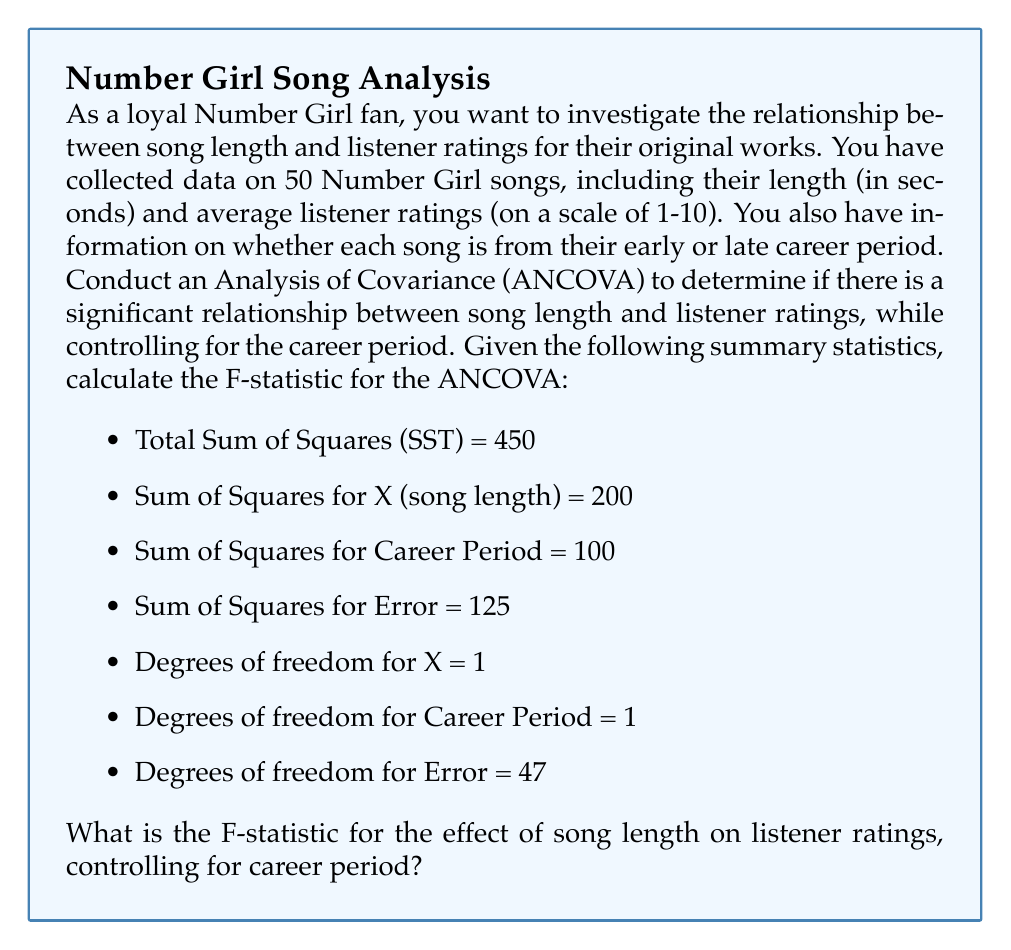Show me your answer to this math problem. To calculate the F-statistic for the effect of song length on listener ratings while controlling for career period, we need to follow these steps:

1. Calculate the Sum of Squares for the covariate (song length) after adjusting for the career period:

   $SS_{X.adj} = SS_X - \frac{(SS_{CP} \times SS_X)}{SST}$

   Where $SS_{X.adj}$ is the adjusted Sum of Squares for X, $SS_X$ is the Sum of Squares for X, $SS_{CP}$ is the Sum of Squares for Career Period, and $SST$ is the Total Sum of Squares.

   $SS_{X.adj} = 200 - \frac{(100 \times 200)}{450} = 200 - 44.44 = 155.56$

2. Calculate the Mean Square for the adjusted X:

   $MS_{X.adj} = \frac{SS_{X.adj}}{df_X}$

   Where $df_X$ is the degrees of freedom for X.

   $MS_{X.adj} = \frac{155.56}{1} = 155.56$

3. Calculate the Mean Square for Error:

   $MS_{Error} = \frac{SS_{Error}}{df_{Error}}$

   Where $SS_{Error}$ is the Sum of Squares for Error, and $df_{Error}$ is the degrees of freedom for Error.

   $MS_{Error} = \frac{125}{47} = 2.66$

4. Calculate the F-statistic:

   $F = \frac{MS_{X.adj}}{MS_{Error}}$

   $F = \frac{155.56}{2.66} = 58.48$

Therefore, the F-statistic for the effect of song length on listener ratings, controlling for career period, is 58.48.
Answer: $F = 58.48$ 